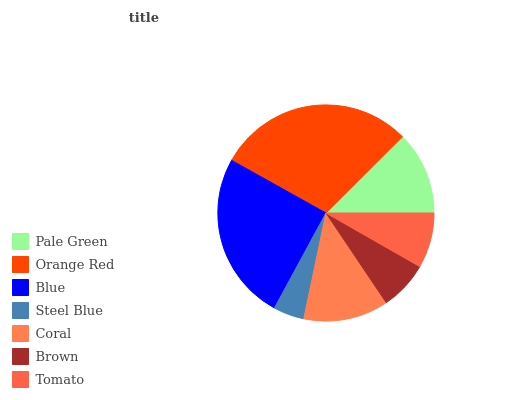Is Steel Blue the minimum?
Answer yes or no. Yes. Is Orange Red the maximum?
Answer yes or no. Yes. Is Blue the minimum?
Answer yes or no. No. Is Blue the maximum?
Answer yes or no. No. Is Orange Red greater than Blue?
Answer yes or no. Yes. Is Blue less than Orange Red?
Answer yes or no. Yes. Is Blue greater than Orange Red?
Answer yes or no. No. Is Orange Red less than Blue?
Answer yes or no. No. Is Pale Green the high median?
Answer yes or no. Yes. Is Pale Green the low median?
Answer yes or no. Yes. Is Blue the high median?
Answer yes or no. No. Is Coral the low median?
Answer yes or no. No. 